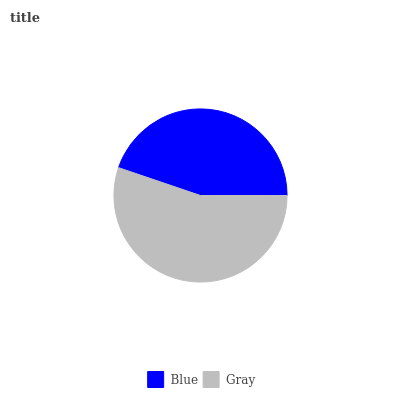Is Blue the minimum?
Answer yes or no. Yes. Is Gray the maximum?
Answer yes or no. Yes. Is Gray the minimum?
Answer yes or no. No. Is Gray greater than Blue?
Answer yes or no. Yes. Is Blue less than Gray?
Answer yes or no. Yes. Is Blue greater than Gray?
Answer yes or no. No. Is Gray less than Blue?
Answer yes or no. No. Is Gray the high median?
Answer yes or no. Yes. Is Blue the low median?
Answer yes or no. Yes. Is Blue the high median?
Answer yes or no. No. Is Gray the low median?
Answer yes or no. No. 